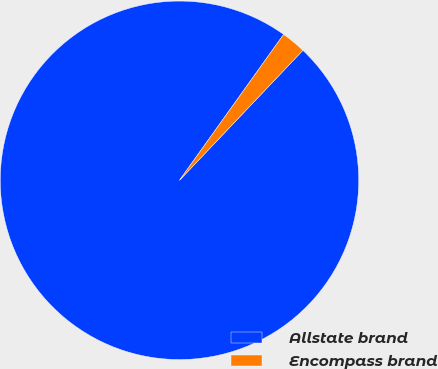Convert chart. <chart><loc_0><loc_0><loc_500><loc_500><pie_chart><fcel>Allstate brand<fcel>Encompass brand<nl><fcel>97.78%<fcel>2.22%<nl></chart> 